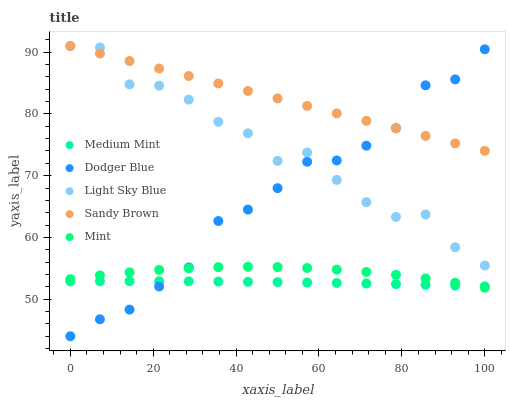Does Medium Mint have the minimum area under the curve?
Answer yes or no. Yes. Does Sandy Brown have the maximum area under the curve?
Answer yes or no. Yes. Does Light Sky Blue have the minimum area under the curve?
Answer yes or no. No. Does Light Sky Blue have the maximum area under the curve?
Answer yes or no. No. Is Sandy Brown the smoothest?
Answer yes or no. Yes. Is Light Sky Blue the roughest?
Answer yes or no. Yes. Is Light Sky Blue the smoothest?
Answer yes or no. No. Is Sandy Brown the roughest?
Answer yes or no. No. Does Dodger Blue have the lowest value?
Answer yes or no. Yes. Does Light Sky Blue have the lowest value?
Answer yes or no. No. Does Light Sky Blue have the highest value?
Answer yes or no. Yes. Does Dodger Blue have the highest value?
Answer yes or no. No. Is Medium Mint less than Light Sky Blue?
Answer yes or no. Yes. Is Sandy Brown greater than Medium Mint?
Answer yes or no. Yes. Does Dodger Blue intersect Light Sky Blue?
Answer yes or no. Yes. Is Dodger Blue less than Light Sky Blue?
Answer yes or no. No. Is Dodger Blue greater than Light Sky Blue?
Answer yes or no. No. Does Medium Mint intersect Light Sky Blue?
Answer yes or no. No. 